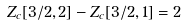<formula> <loc_0><loc_0><loc_500><loc_500>Z _ { c } [ 3 / 2 , 2 ] - Z _ { c } [ 3 / 2 , 1 ] = 2</formula> 